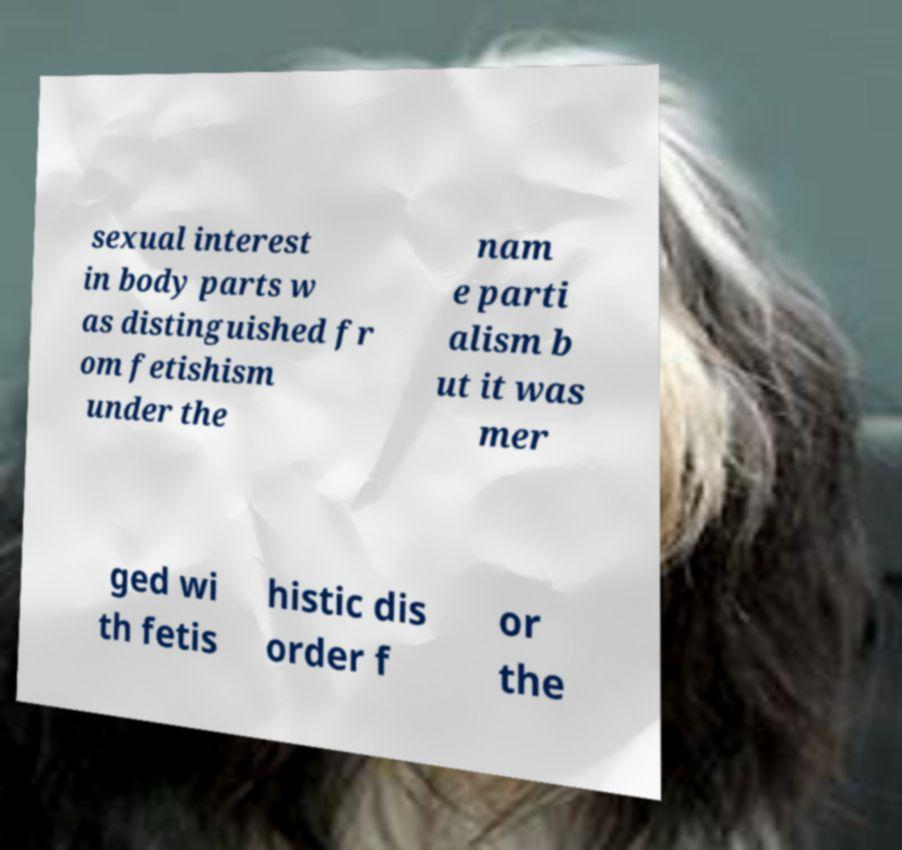Can you accurately transcribe the text from the provided image for me? sexual interest in body parts w as distinguished fr om fetishism under the nam e parti alism b ut it was mer ged wi th fetis histic dis order f or the 